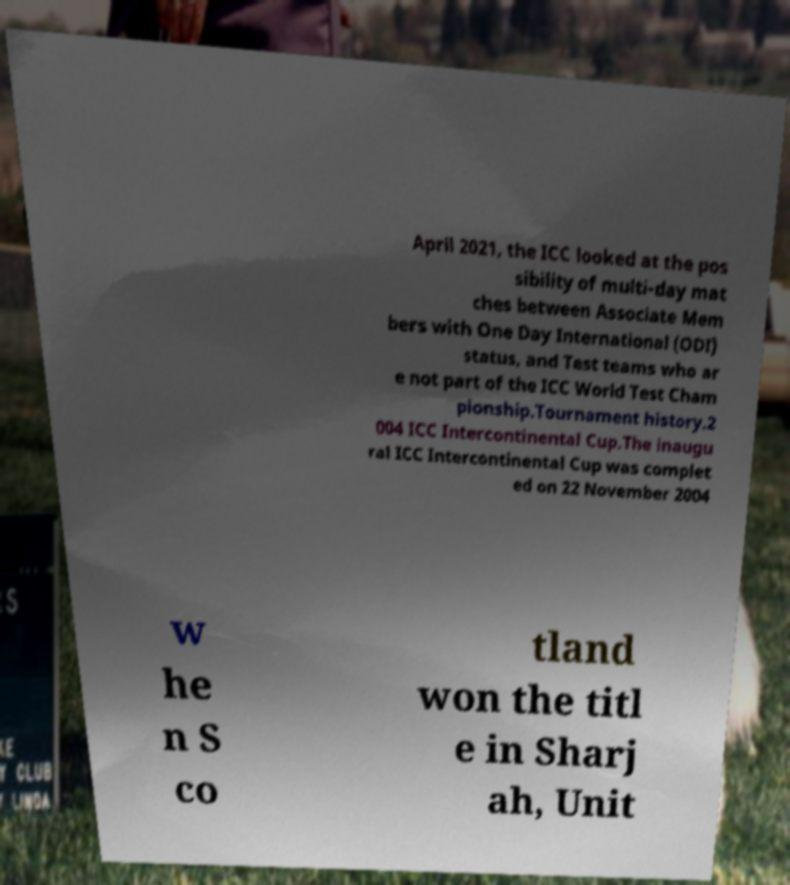Could you assist in decoding the text presented in this image and type it out clearly? April 2021, the ICC looked at the pos sibility of multi-day mat ches between Associate Mem bers with One Day International (ODI) status, and Test teams who ar e not part of the ICC World Test Cham pionship.Tournament history.2 004 ICC Intercontinental Cup.The inaugu ral ICC Intercontinental Cup was complet ed on 22 November 2004 w he n S co tland won the titl e in Sharj ah, Unit 